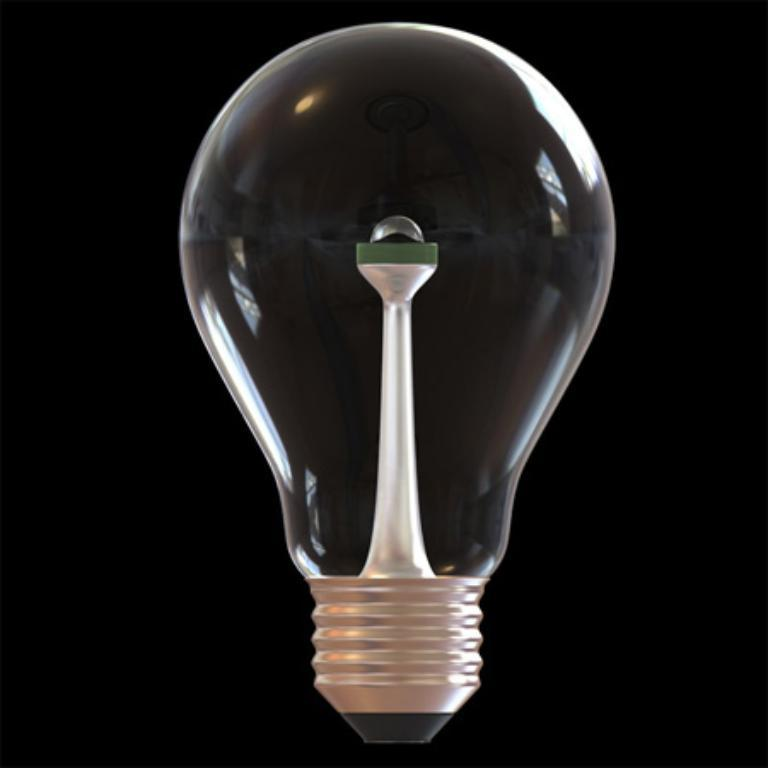What is the main source of light in the image? There is a light in the front of the image. What can be observed about the background of the image? The background of the image is dark. Can you see a robin reading a book in the image? There is no robin or book present in the image. 